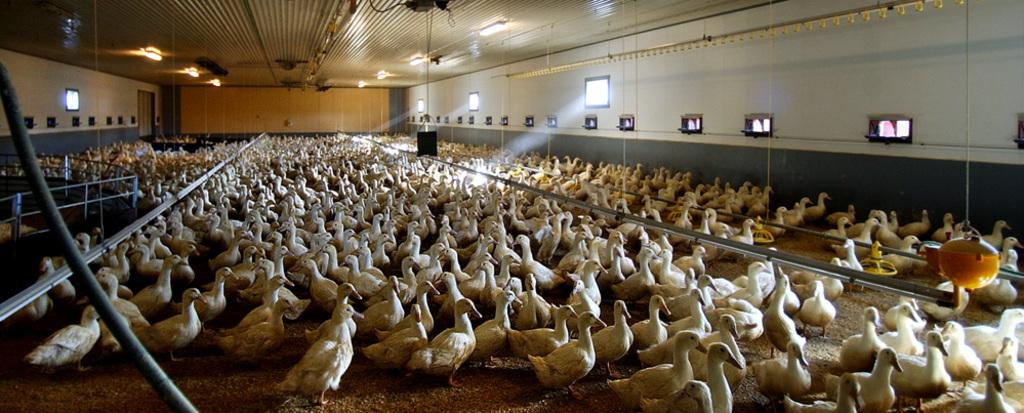What type of animals are on the ground in the image? There is a group of white birds on the ground in the image. What can be seen on the wall in the image? There is a wall with windows and other objects in the image. What type of barrier is present in the image? There is a fence in the image. What is present on the ceiling in the image? There are lights on the ceiling in the image. How many apples are being held by the finger in the image? There are no apples or fingers present in the image. What is the front of the image showing? The provided facts do not specify a front or back of the image, so it cannot be determined from the information given. 